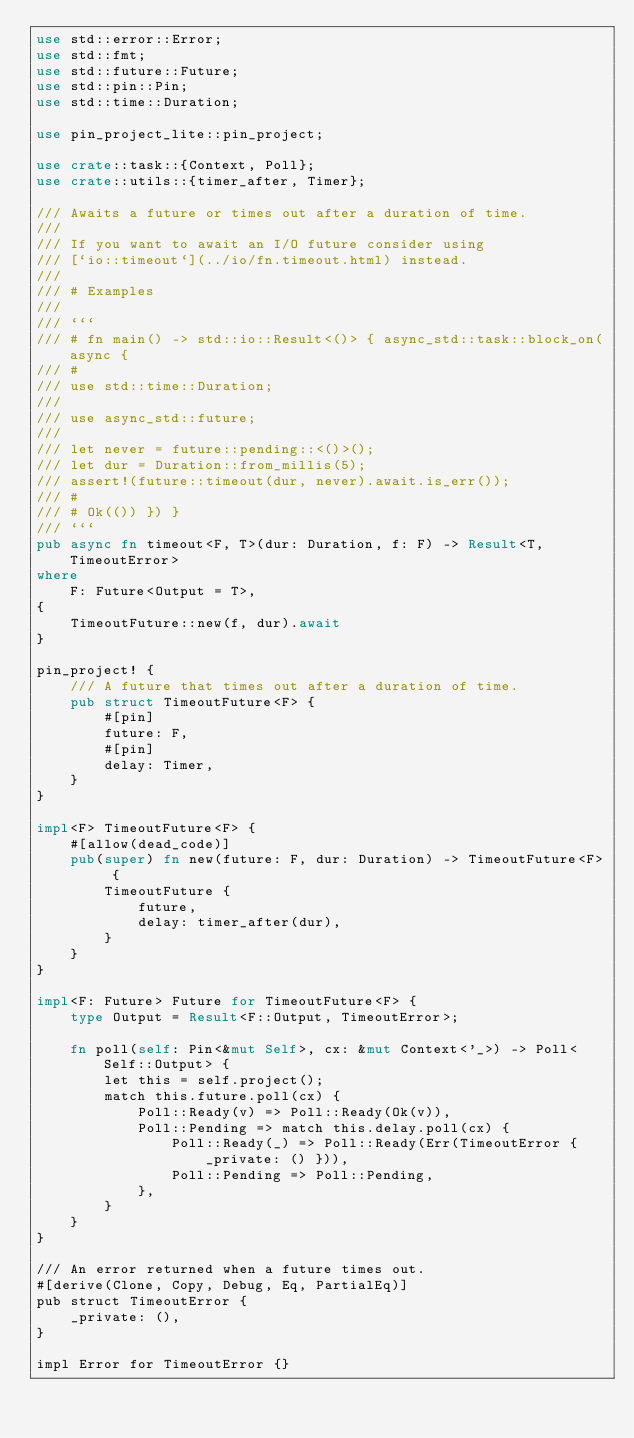Convert code to text. <code><loc_0><loc_0><loc_500><loc_500><_Rust_>use std::error::Error;
use std::fmt;
use std::future::Future;
use std::pin::Pin;
use std::time::Duration;

use pin_project_lite::pin_project;

use crate::task::{Context, Poll};
use crate::utils::{timer_after, Timer};

/// Awaits a future or times out after a duration of time.
///
/// If you want to await an I/O future consider using
/// [`io::timeout`](../io/fn.timeout.html) instead.
///
/// # Examples
///
/// ```
/// # fn main() -> std::io::Result<()> { async_std::task::block_on(async {
/// #
/// use std::time::Duration;
///
/// use async_std::future;
///
/// let never = future::pending::<()>();
/// let dur = Duration::from_millis(5);
/// assert!(future::timeout(dur, never).await.is_err());
/// #
/// # Ok(()) }) }
/// ```
pub async fn timeout<F, T>(dur: Duration, f: F) -> Result<T, TimeoutError>
where
    F: Future<Output = T>,
{
    TimeoutFuture::new(f, dur).await
}

pin_project! {
    /// A future that times out after a duration of time.
    pub struct TimeoutFuture<F> {
        #[pin]
        future: F,
        #[pin]
        delay: Timer,
    }
}

impl<F> TimeoutFuture<F> {
    #[allow(dead_code)]
    pub(super) fn new(future: F, dur: Duration) -> TimeoutFuture<F> {
        TimeoutFuture {
            future,
            delay: timer_after(dur),
        }
    }
}

impl<F: Future> Future for TimeoutFuture<F> {
    type Output = Result<F::Output, TimeoutError>;

    fn poll(self: Pin<&mut Self>, cx: &mut Context<'_>) -> Poll<Self::Output> {
        let this = self.project();
        match this.future.poll(cx) {
            Poll::Ready(v) => Poll::Ready(Ok(v)),
            Poll::Pending => match this.delay.poll(cx) {
                Poll::Ready(_) => Poll::Ready(Err(TimeoutError { _private: () })),
                Poll::Pending => Poll::Pending,
            },
        }
    }
}

/// An error returned when a future times out.
#[derive(Clone, Copy, Debug, Eq, PartialEq)]
pub struct TimeoutError {
    _private: (),
}

impl Error for TimeoutError {}
</code> 